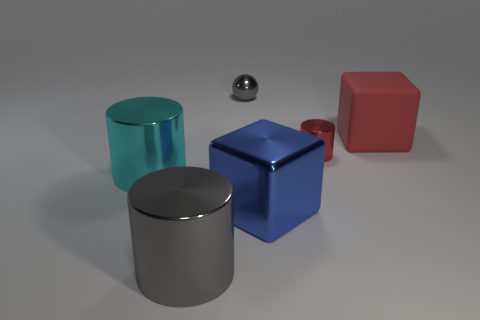Add 3 red things. How many objects exist? 9 Subtract all balls. How many objects are left? 5 Add 6 red matte blocks. How many red matte blocks are left? 7 Add 4 small red metal cylinders. How many small red metal cylinders exist? 5 Subtract 1 red cubes. How many objects are left? 5 Subtract all big blue shiny objects. Subtract all large metal things. How many objects are left? 2 